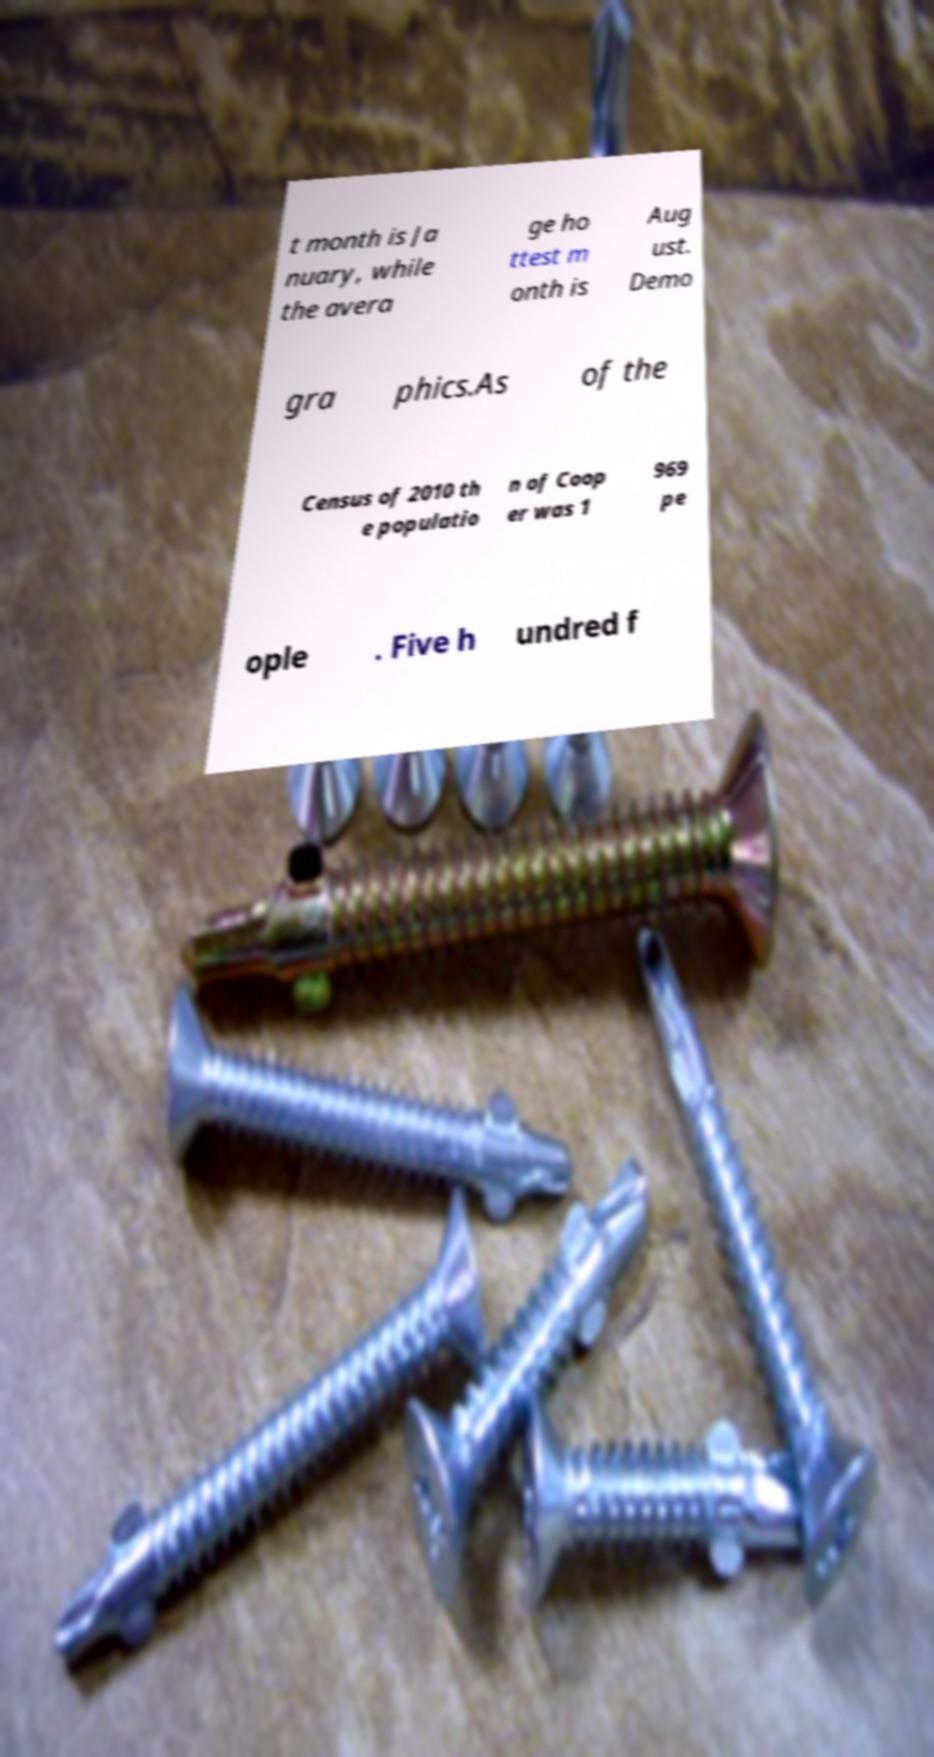Please read and relay the text visible in this image. What does it say? t month is Ja nuary, while the avera ge ho ttest m onth is Aug ust. Demo gra phics.As of the Census of 2010 th e populatio n of Coop er was 1 969 pe ople . Five h undred f 